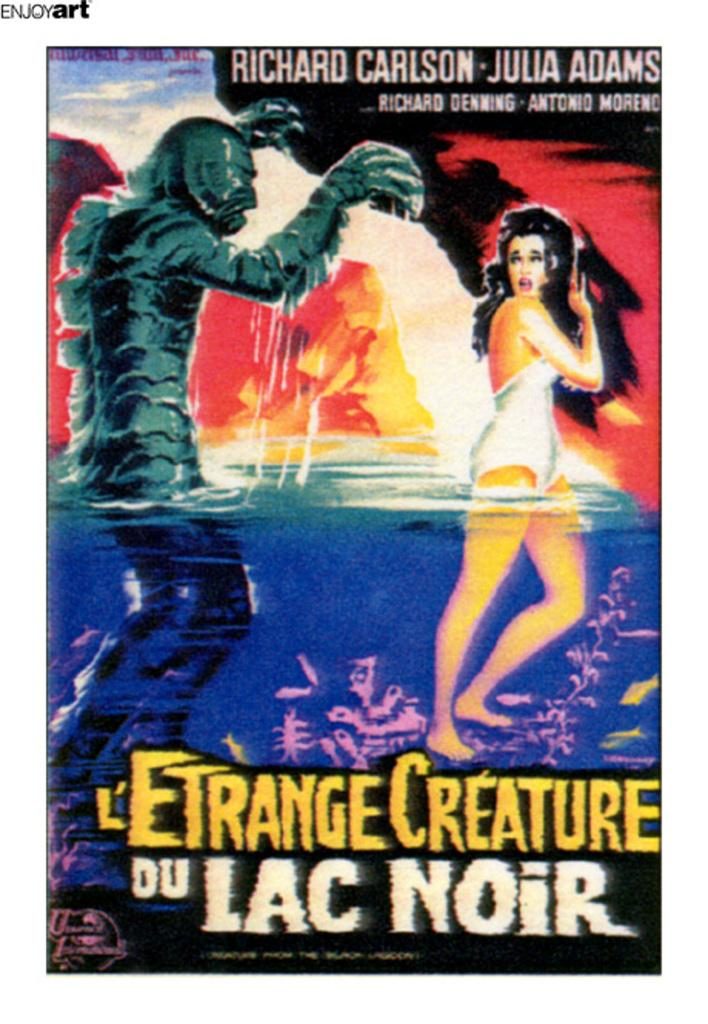<image>
Share a concise interpretation of the image provided. Poster showing a monster hunting a woman with the name Richard Carlson on top. 